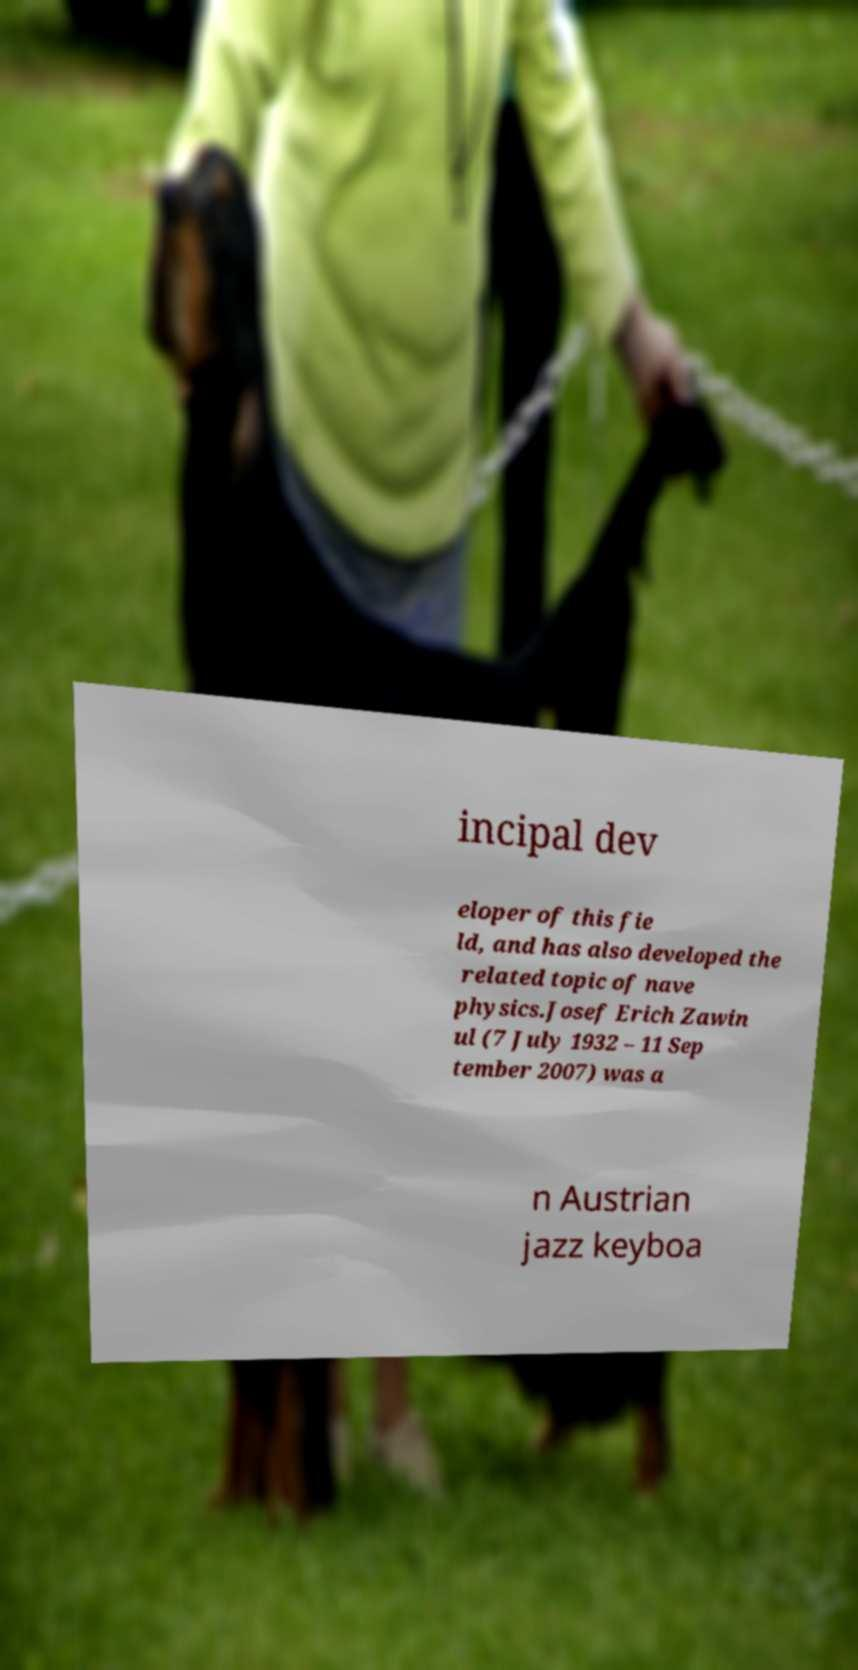Please read and relay the text visible in this image. What does it say? incipal dev eloper of this fie ld, and has also developed the related topic of nave physics.Josef Erich Zawin ul (7 July 1932 – 11 Sep tember 2007) was a n Austrian jazz keyboa 